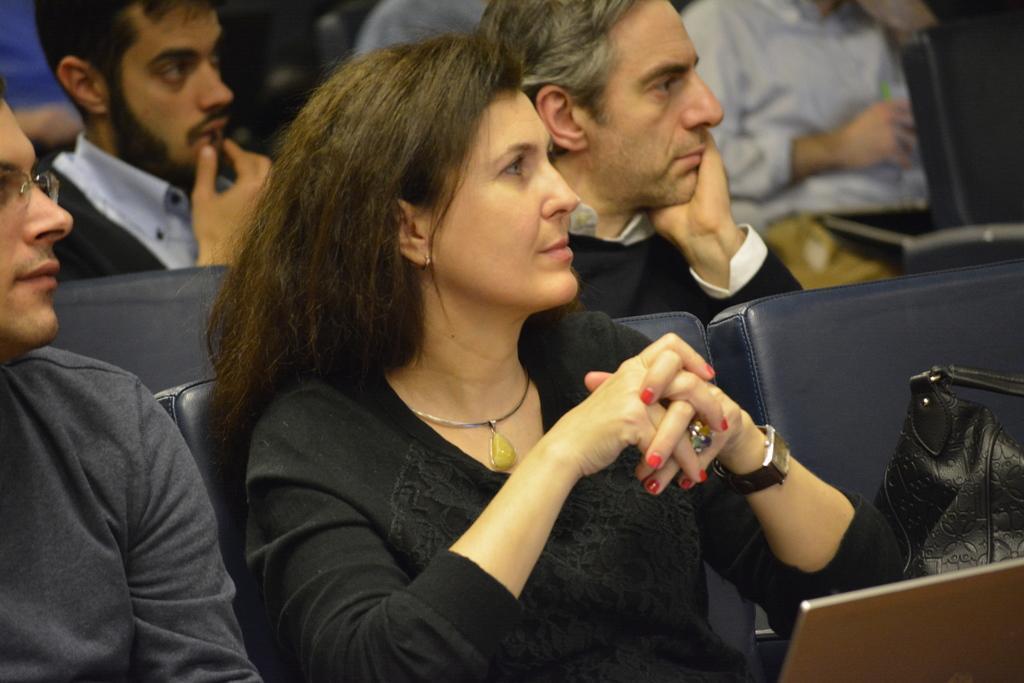Could you give a brief overview of what you see in this image? In this image we can see some persons, chairs and other objects. 